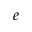<formula> <loc_0><loc_0><loc_500><loc_500>_ { e }</formula> 